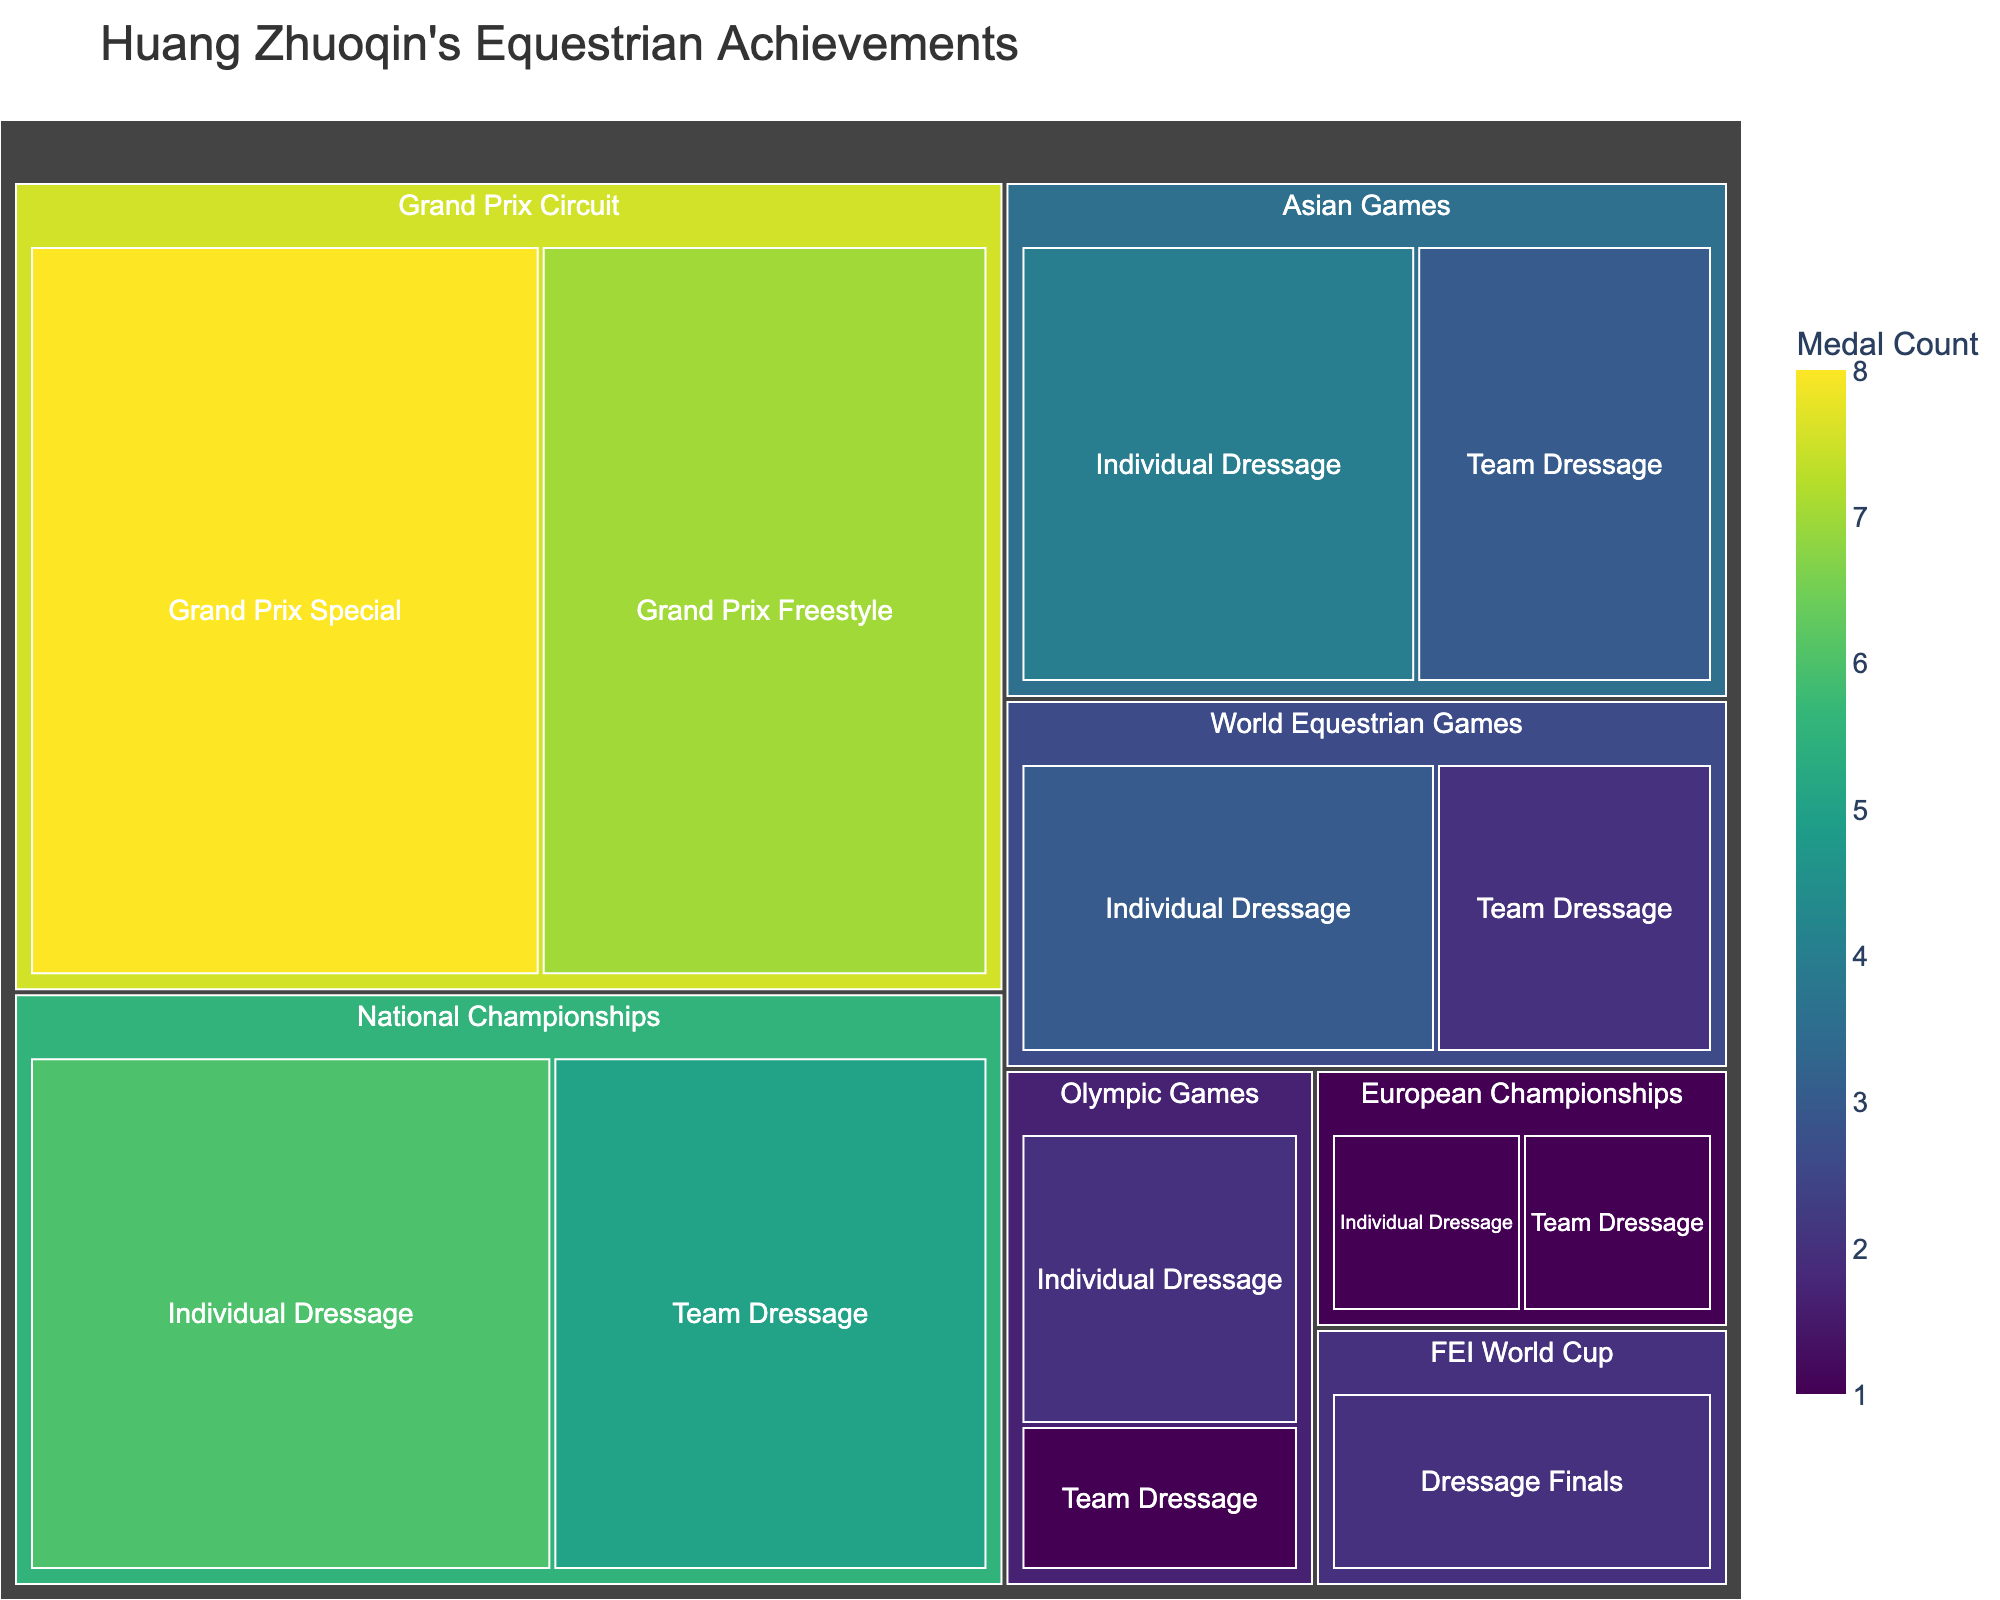How many medals did Huang Zhuoqin win in Asia? Sum the medals from the Asian Games category, which includes Individual Dressage and Team Dressage: 4 + 3
Answer: 7 Which competition did Huang Zhuoqin win the most medals in? Look for the competition with the largest area in the treemap, labeled with the highest number of medals. Grand Prix Circuit (Grand Prix Special: 8 and Grand Prix Freestyle: 7) has the most medals.
Answer: Grand Prix Circuit How many more medals did Huang Zhuoqin win in Individual Dressage compared to Team Dressage overall? Calculate the total medals in Individual Dressage and Team Dressage across all categories. Individual Dressage: 2 (Olympic Games) + 3 (World Equestrian Games) + 4 (Asian Games) + 6 (National Championships) + 1 (European Championships) = 16; Team Dressage: 1 (Olympic Games) + 2 (World Equestrian Games) + 3 (Asian Games) + 5 (National Championships) + 1 (European Championships) = 12; 16 - 12 = 4
Answer: 4 What percentage of the total medals did Huang Zhuoqin win in the Olympic Games? Sum all the medals to find the total: 2 (Olympic) + 1 (Olympic) + 3 (World Equestrian Games) + 2 (World Equestrian Games) + 4 (Asian Games) + 3 (Asian Games) + 2 (FEI World Cup) + 1 (European Championships) + 1 (European Championships) + 6 (National Championships) + 5 (National Championships) + 8 (Grand Prix Circuit) + 7 (Grand Prix Circuit) = 45. Then calculate the percentage for the Olympic Games: (2 + 1) / 45 * 100
Answer: 6.67% In which category did Huang Zhuoqin win the least number of medals? Look for the category with the smallest area in the treemap. It is FEI World Cup with 2 medals.
Answer: FEI World Cup By how many medals does Grand Prix Special exceed Olympic Games Individual Dressage? Look at the Grand Prix Special (8 medals) and Olympic Games Individual Dressage (2 medals) and find the difference: 8 - 2
Answer: 6 How many total medals were won in World Equestrian Games? Sum the medals in the World Equestrian Games category: 3 (Individual Dressage) + 2 (Team Dressage) = 5
Answer: 5 Which individual dressage event has the highest number of medals? Compare the Individual Dressage events in each category. National Championships has the highest with 6 medals.
Answer: National Championships 